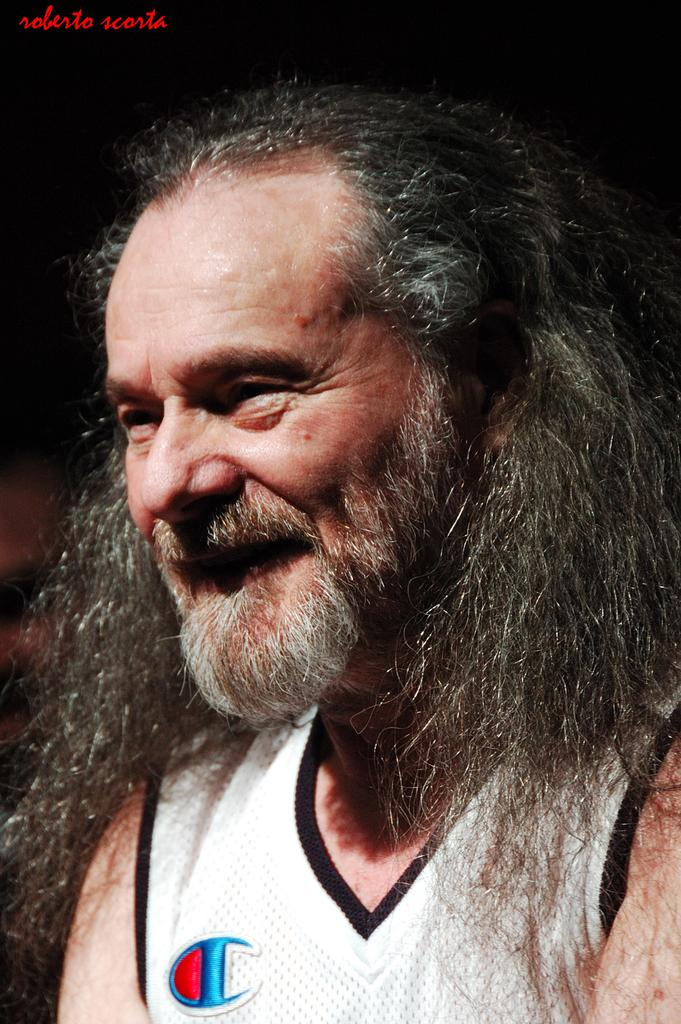Who is present in the image? There is a man in the image. What else can be seen in the image besides the man? There is text in the image. What type of object is the image contained within? The image appears to be a photo frame. What type of bead is used to decorate the man's clothing in the image? There is no bead or any type of clothing decoration visible on the man in the image. Can you tell me how many monkeys are present in the image? There are no monkeys present in the image; it features a man and text. 